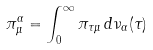<formula> <loc_0><loc_0><loc_500><loc_500>\pi _ { \mu } ^ { \alpha } = \int _ { 0 } ^ { \infty } \pi _ { \tau \mu } \, d \nu _ { \alpha } ( \tau )</formula> 